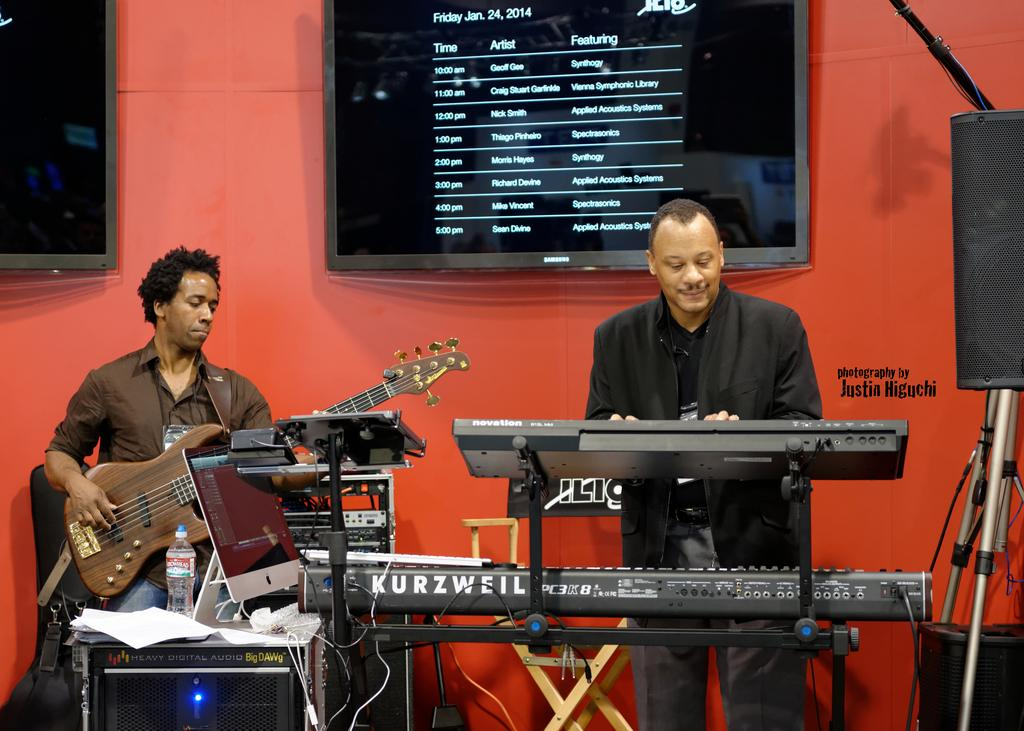How many people are in the image? There are two men in the image. What are the men doing in the image? The men are playing musical instruments. What can be seen in the background of the image? There is a screen with a list in the background of the image. Can you see an owl perched on the musical instruments in the image? No, there is no owl present in the image. What type of soda is being served at the event in the image? There is no event or soda mentioned in the image; it only shows two men playing musical instruments and a screen with a list in the background. 